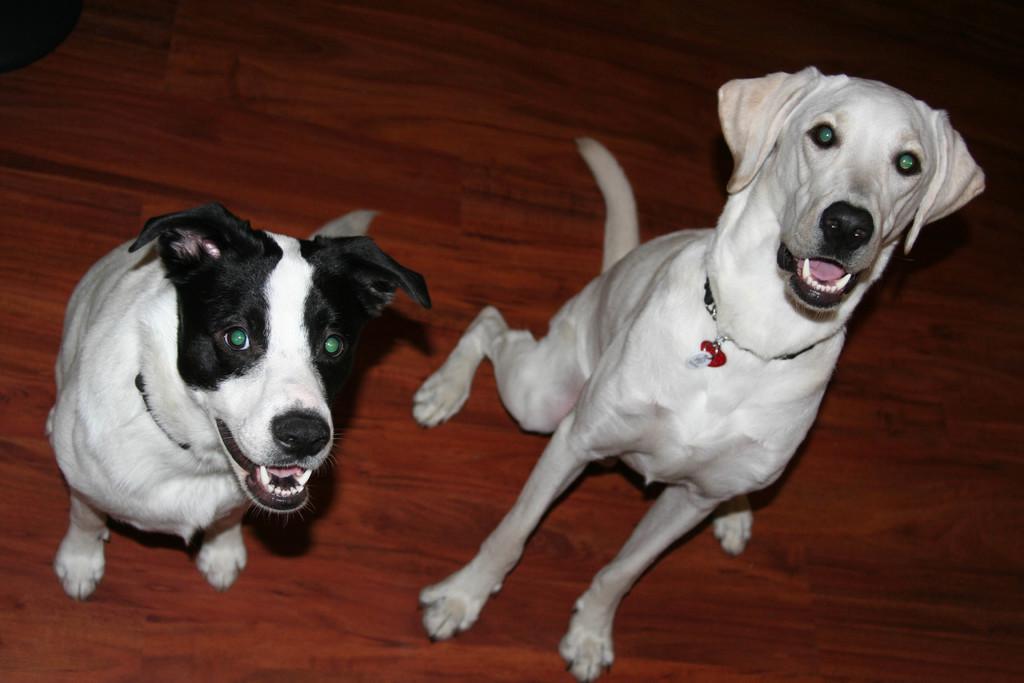Could you give a brief overview of what you see in this image? In this picture we can see two dogs on a wooden surface. 